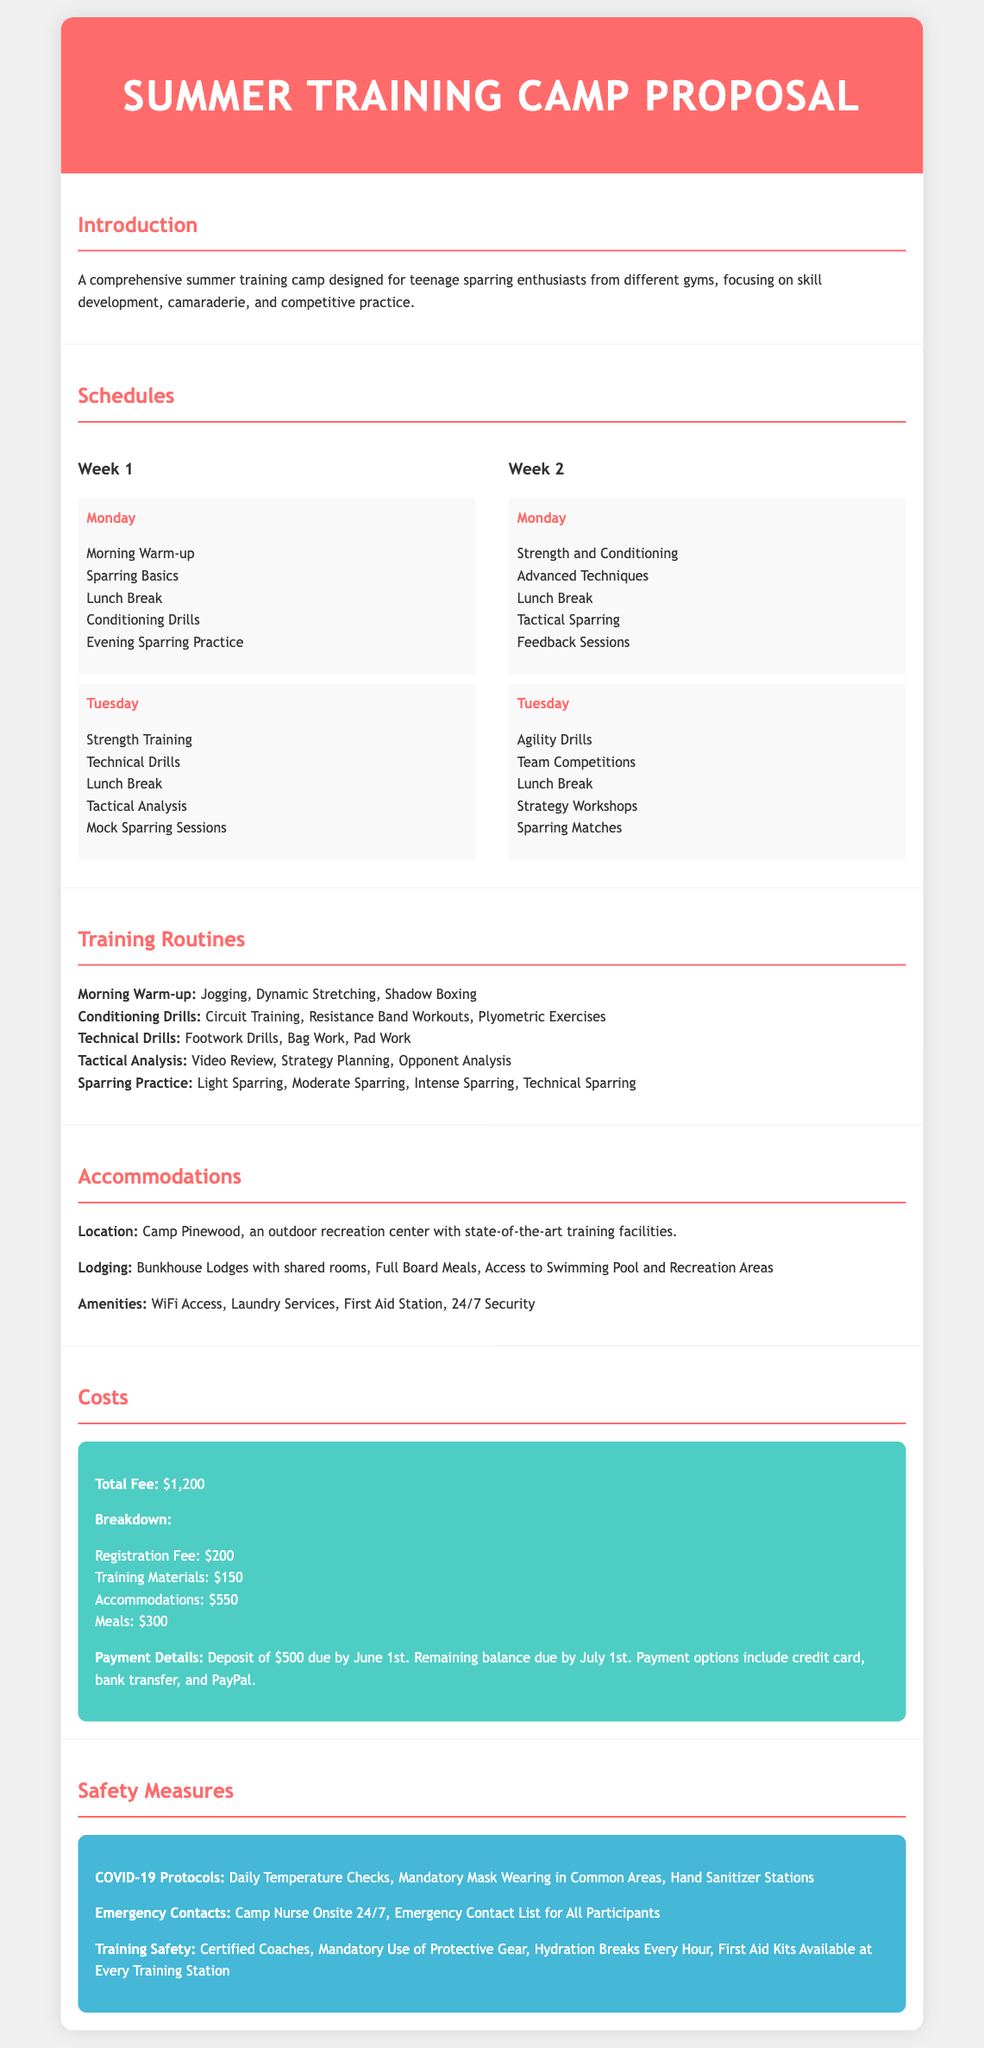What is the total fee for the summer training camp? The total fee is outlined in the Costs section of the document as $1,200.
Answer: $1,200 What amenities are provided at the lodging? The Accommodations section lists multiple amenities, including WiFi Access and Laundry Services.
Answer: WiFi Access, Laundry Services How many weeks does the training camp run? The Schedules section displays two weeks of training, labeled as Week 1 and Week 2.
Answer: Two weeks What safety measure is implemented for COVID-19? The Safety Measures section specifies Daily Temperature Checks as one of the safety protocols.
Answer: Daily Temperature Checks What is the registration fee? The Costs section includes a breakdown where the Registration Fee is stated as $200.
Answer: $200 What type of drills are included in the morning routine? The Training Routines section mentions Morning Warm-up, which includes Jogging and Dynamic Stretching.
Answer: Jogging, Dynamic Stretching What is the payment option deadline? The Costs section indicates that the remaining balance is due by July 1st.
Answer: July 1st What type of lodging is provided? The Accommodations section describes Bunkhouse Lodges with shared rooms.
Answer: Bunkhouse Lodges with shared rooms 